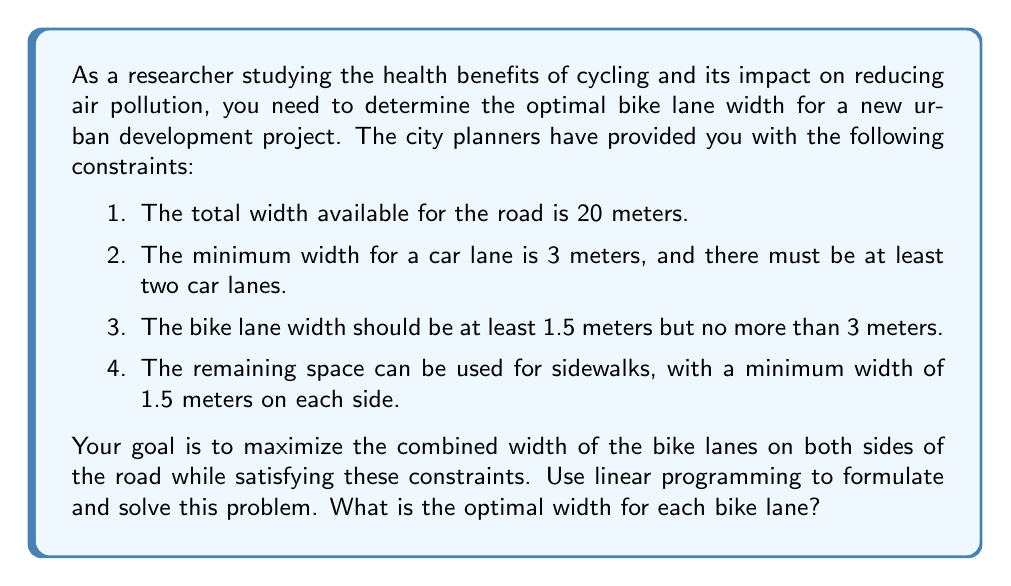What is the answer to this math problem? Let's approach this problem step-by-step using linear programming:

1. Define variables:
   $x$ = width of each bike lane (in meters)
   $y$ = width of each car lane (in meters)
   $z$ = width of each sidewalk (in meters)

2. Objective function:
   Maximize: $2x$ (total width of both bike lanes)

3. Constraints:
   a) Total width: $2x + 2y + 2z = 20$
   b) Minimum car lane width: $y \geq 3$
   c) Minimum bike lane width: $x \geq 1.5$
   d) Maximum bike lane width: $x \leq 3$
   e) Minimum sidewalk width: $z \geq 1.5$

4. Simplify the problem:
   From constraint (a), we can express $z$ in terms of $x$ and $y$:
   $z = 10 - x - y$

5. Substitute this into constraint (e):
   $10 - x - y \geq 1.5$
   $-x - y \geq -8.5$
   $x + y \leq 8.5$

6. Our simplified linear programming problem:
   Maximize: $2x$
   Subject to:
   $y \geq 3$
   $1.5 \leq x \leq 3$
   $x + y \leq 8.5$

7. Solve graphically or using the simplex method:
   The optimal solution will occur at one of the corners of the feasible region. The corners are:
   (1.5, 3), (3, 3), (3, 5.5), (1.5, 7)

8. Evaluate the objective function at each corner:
   (1.5, 3): $2x = 2(1.5) = 3$
   (3, 3): $2x = 2(3) = 6$
   (3, 5.5): $2x = 2(3) = 6$
   (1.5, 7): $2x = 2(1.5) = 3$

9. The maximum value of the objective function occurs at (3, 3) and (3, 5.5). Both give the same optimal bike lane width.

Therefore, the optimal width for each bike lane is 3 meters.
Answer: 3 meters 